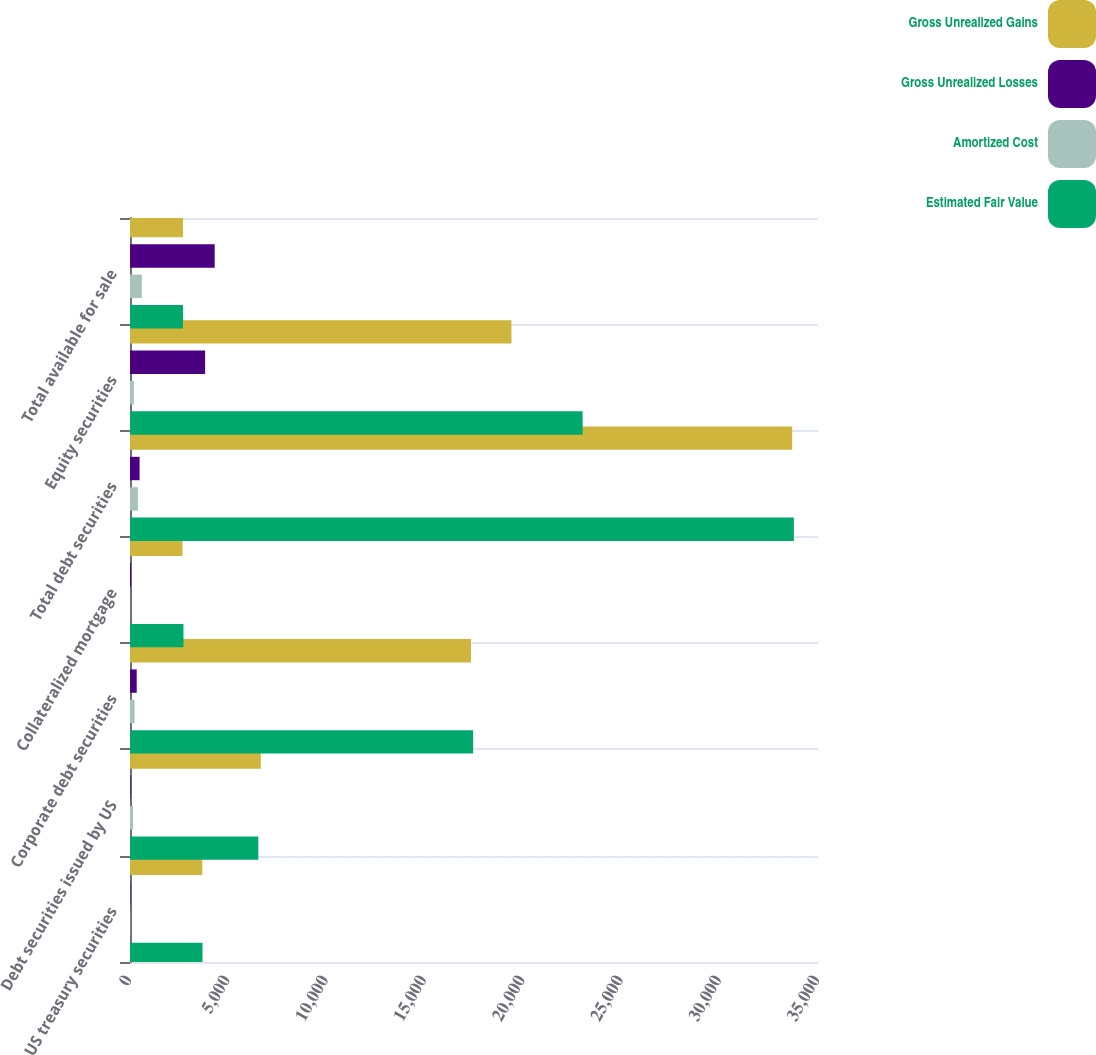<chart> <loc_0><loc_0><loc_500><loc_500><stacked_bar_chart><ecel><fcel>US treasury securities<fcel>Debt securities issued by US<fcel>Corporate debt securities<fcel>Collateralized mortgage<fcel>Total debt securities<fcel>Equity securities<fcel>Total available for sale<nl><fcel>Gross Unrealized Gains<fcel>3679<fcel>6654<fcel>17347<fcel>2671<fcel>33687<fcel>19405<fcel>2695.5<nl><fcel>Gross Unrealized Losses<fcel>20<fcel>29<fcel>341<fcel>53<fcel>488<fcel>3821<fcel>4309<nl><fcel>Amortized Cost<fcel>11<fcel>155<fcel>232<fcel>4<fcel>402<fcel>199<fcel>601<nl><fcel>Estimated Fair Value<fcel>3688<fcel>6528<fcel>17456<fcel>2720<fcel>33773<fcel>23027<fcel>2695.5<nl></chart> 